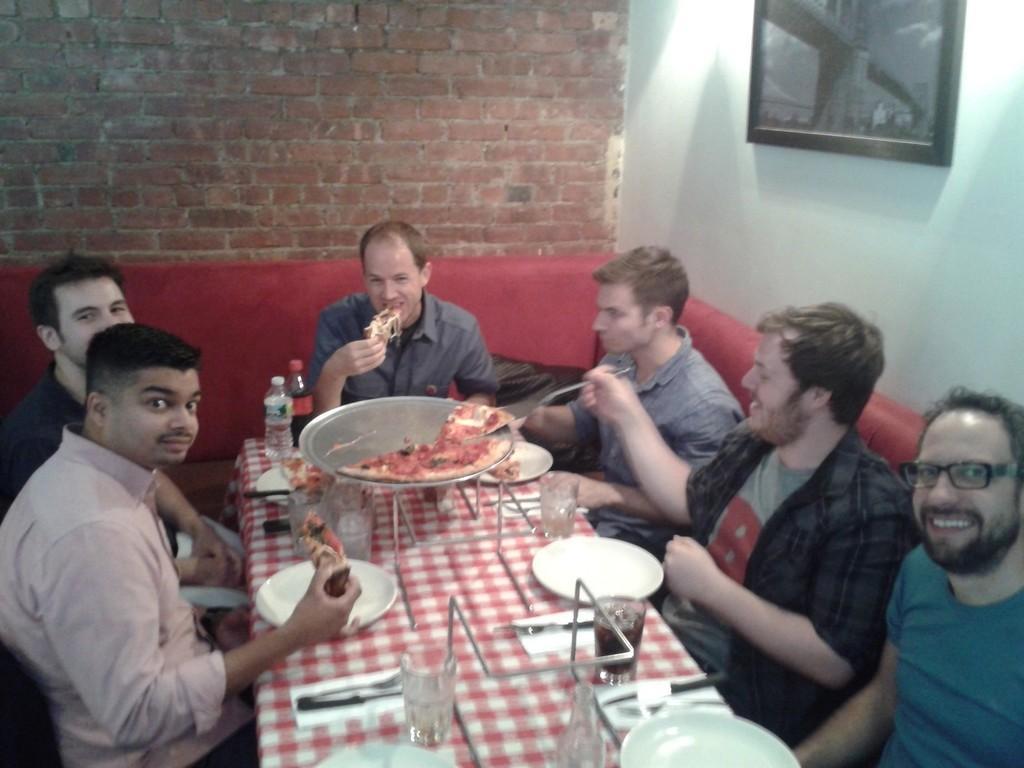Please provide a concise description of this image. In this image the persons are sitting on a sofa and having food together. The man at the bottom right is having smile on his face. The man in the center is eating. The man at the left side is holding food in his hand. In the background there is a wall with red colour bricks. At the right side frame is hanged on the wall. On the table there are glasses, plates. 